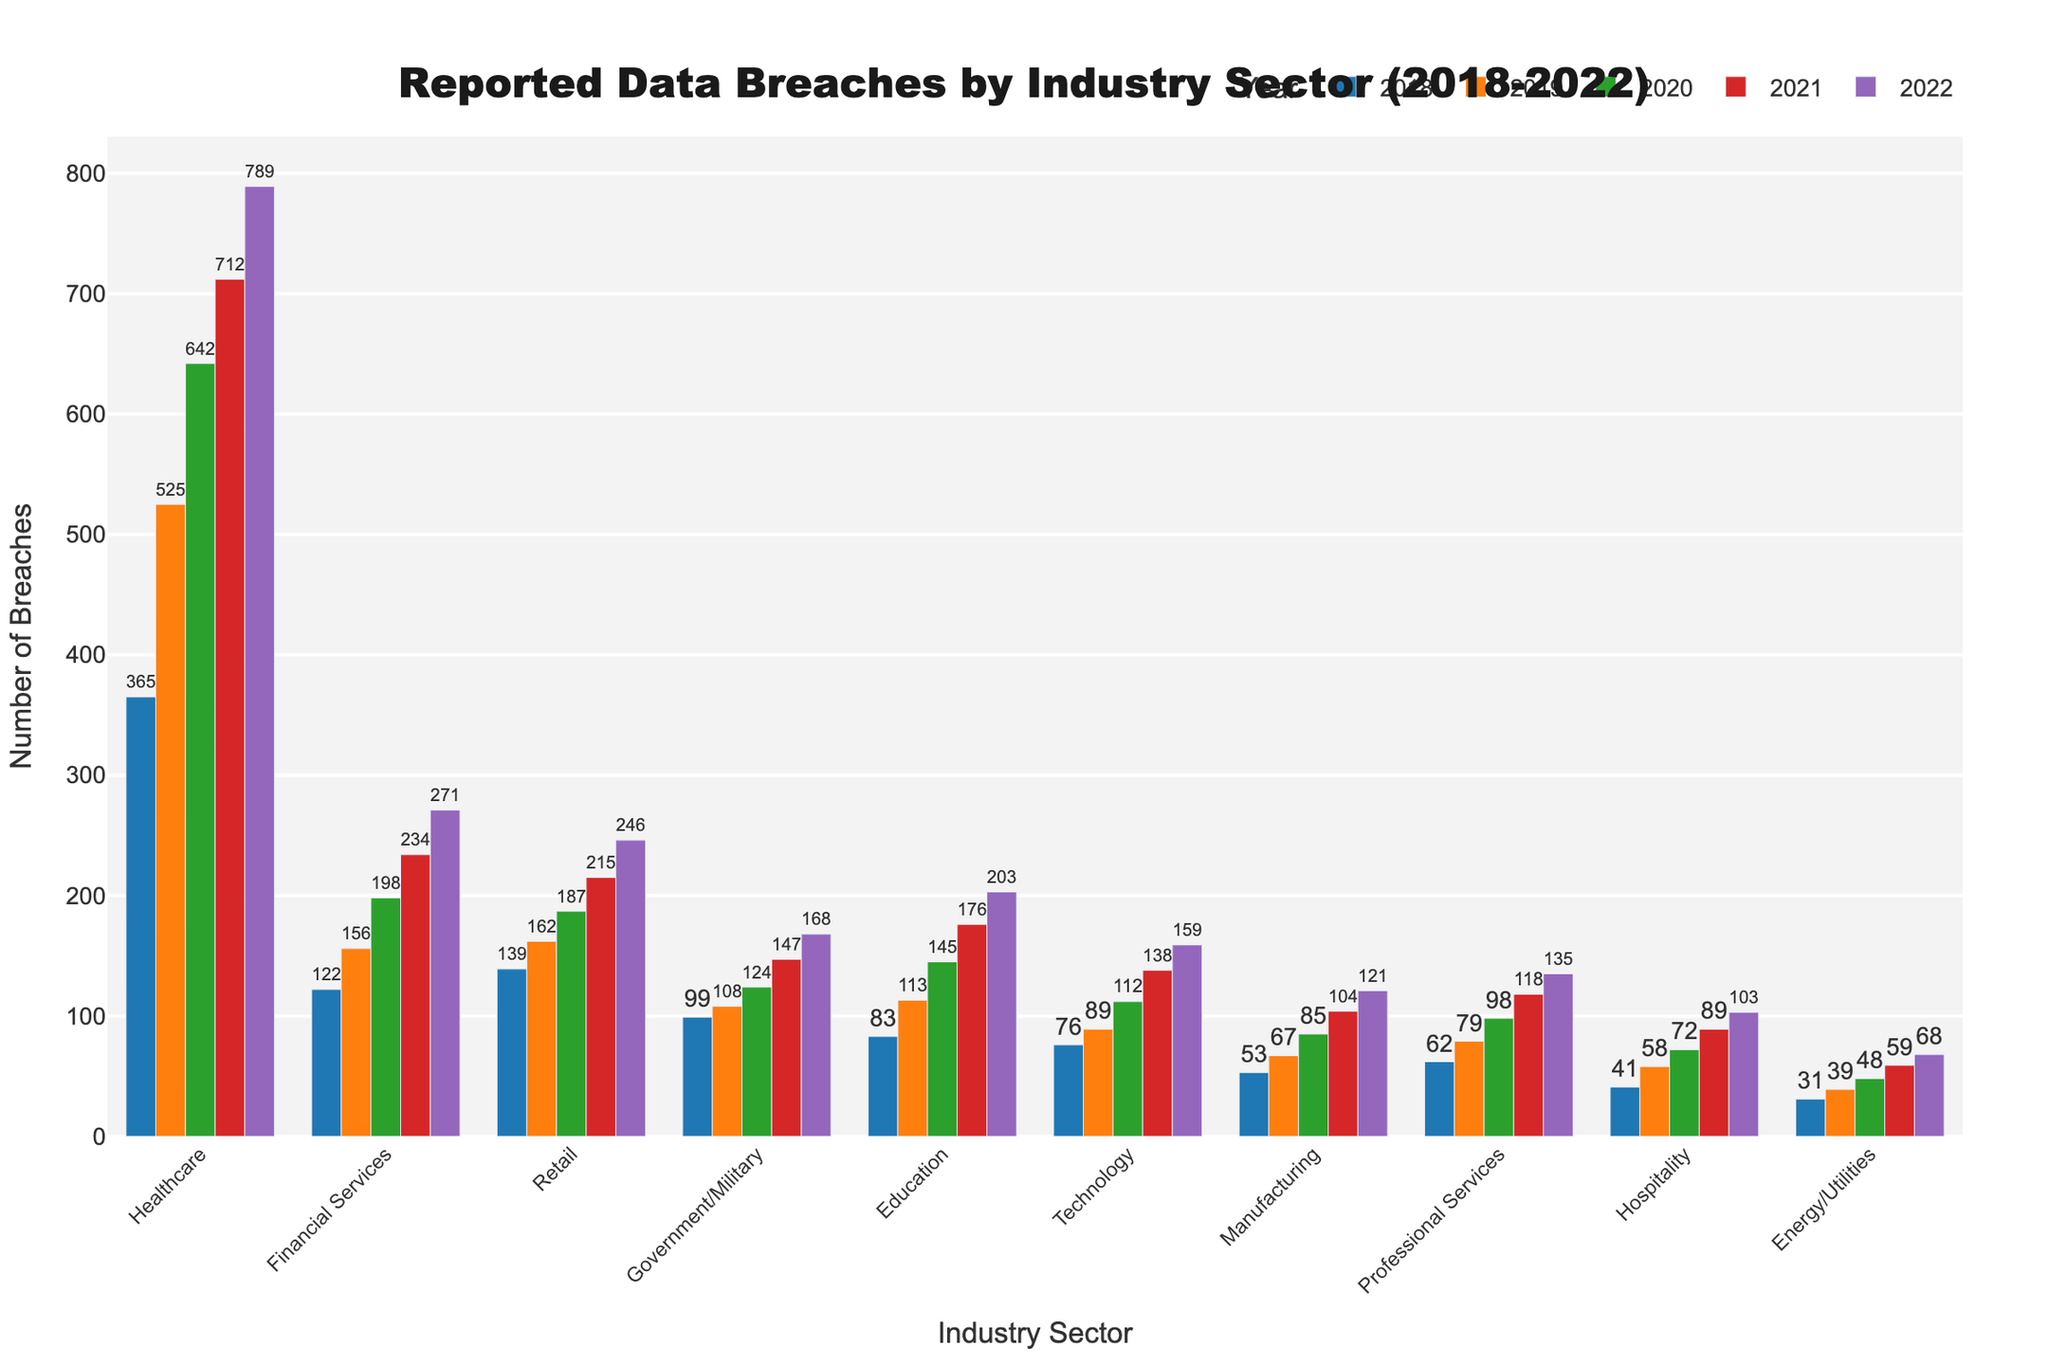Which industry sector reported the highest number of data breaches in 2022? Looking at the bars for the year 2022, we observe that the Healthcare sector has the tallest bar.
Answer: Healthcare How many data breaches were reported in the Technology sector in 2020? By finding the bar corresponding to the Technology sector and the year 2020, we can see the value at the top of the bar is 112.
Answer: 112 Which industry had more breaches in 2021, Retail or Government/Military? Comparing the heights of the bars for Retail and Government/Military in 2021, Retail has a taller bar, indicating more breaches.
Answer: Retail What is the total number of data breaches reported in the Healthcare sector from 2018 to 2022? Summing the breaches for Healthcare from 2018 (365), 2019 (525), 2020 (642), 2021 (712), and 2022 (789), we get 3033.
Answer: 3033 Did the number of reported data breaches in Financial Services increase or decrease from 2019 to 2020? Comparing the bars for Financial Services in 2019 (156) and 2020 (198), there is an increase.
Answer: Increase In which year did the Education sector report the highest number of data breaches? Observing the heights of the bars for all years under Education, we see the highest bar in 2022.
Answer: 2022 What is the difference in the number of breaches between Manufacturing and Hospitality in 2022? The number of breaches in Manufacturing in 2022 is 121, and in Hospitality, it is 103, resulting in a difference of 18.
Answer: 18 Which sector had a greater increase in breaches from 2020 to 2021: Professional Services or Technology? The increase in Professional Services is from 98 to 118 (20), and the increase in Technology is from 112 to 138 (26). Technology had the greater increase.
Answer: Technology How many sectors reported at least 200 breaches in 2022? Counting the bars for 2022 with values above 200: Healthcare (789), Financial Services (271), Retail (246), and Education (203), totaling 4 sectors.
Answer: 4 Was there any decrease in the number of breaches for any industry sector from 2018 to 2019? Checking the bars from 2018 to 2019 for all sectors, we see no sector experienced a decrease—all either increased or remained the same.
Answer: No 